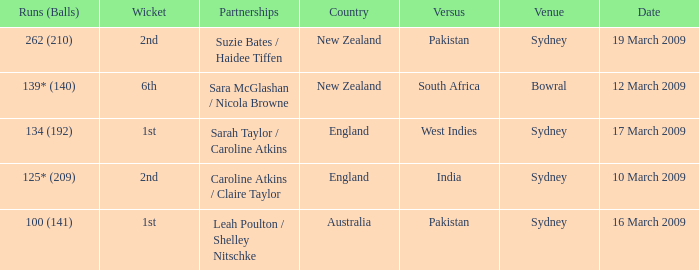How many occasions was the rival country india? 1.0. 